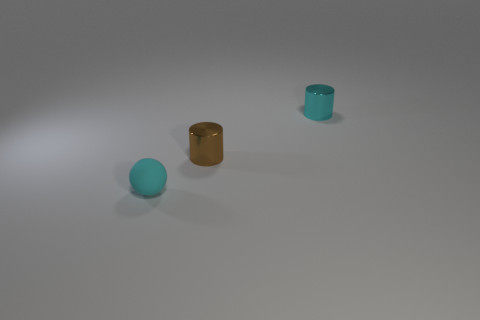Add 2 small cyan rubber things. How many objects exist? 5 Subtract all cylinders. How many objects are left? 1 Subtract all brown cylinders. Subtract all brown cubes. How many cylinders are left? 1 Subtract all tiny purple rubber blocks. Subtract all cylinders. How many objects are left? 1 Add 2 cyan metallic things. How many cyan metallic things are left? 3 Add 2 small brown cylinders. How many small brown cylinders exist? 3 Subtract 0 yellow cylinders. How many objects are left? 3 